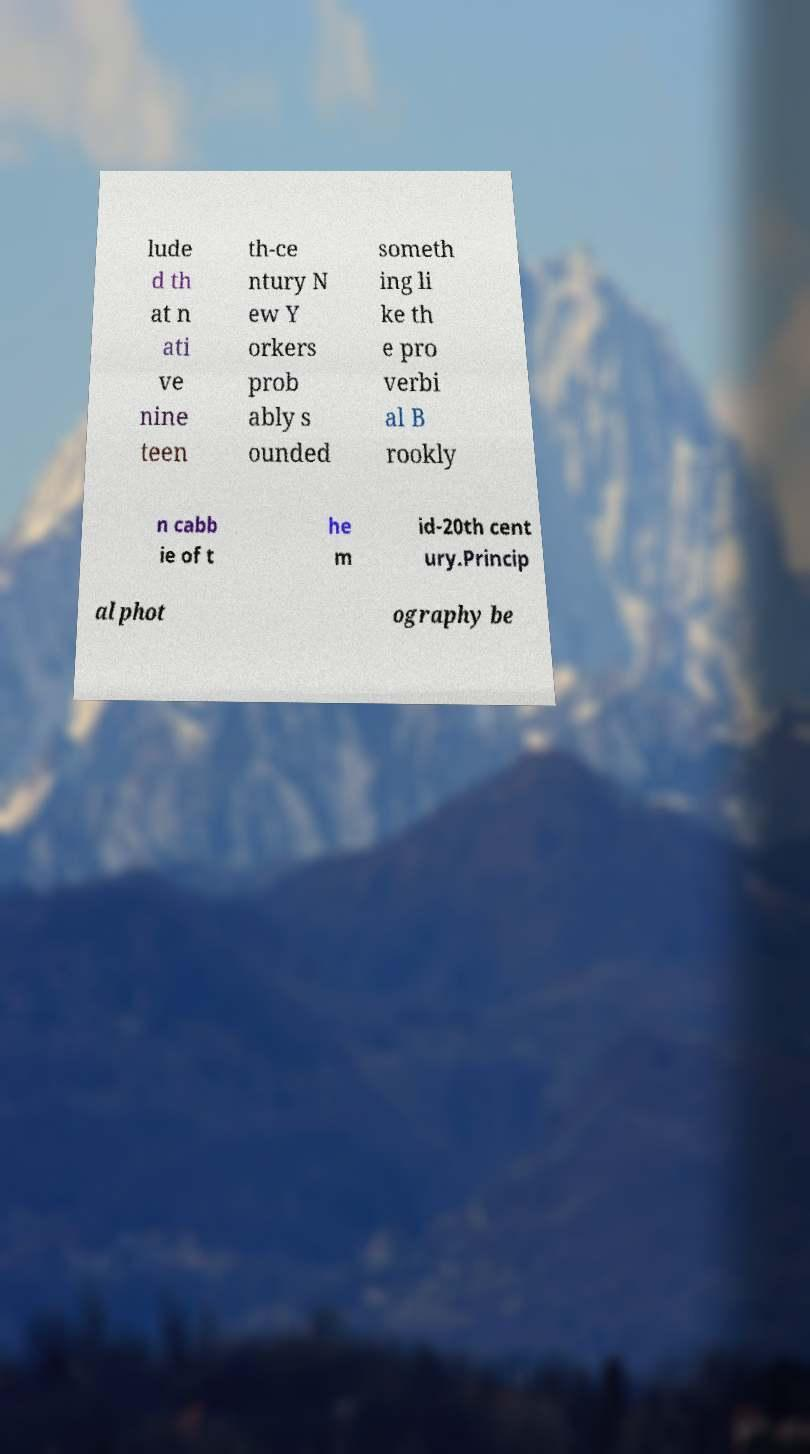I need the written content from this picture converted into text. Can you do that? lude d th at n ati ve nine teen th-ce ntury N ew Y orkers prob ably s ounded someth ing li ke th e pro verbi al B rookly n cabb ie of t he m id-20th cent ury.Princip al phot ography be 